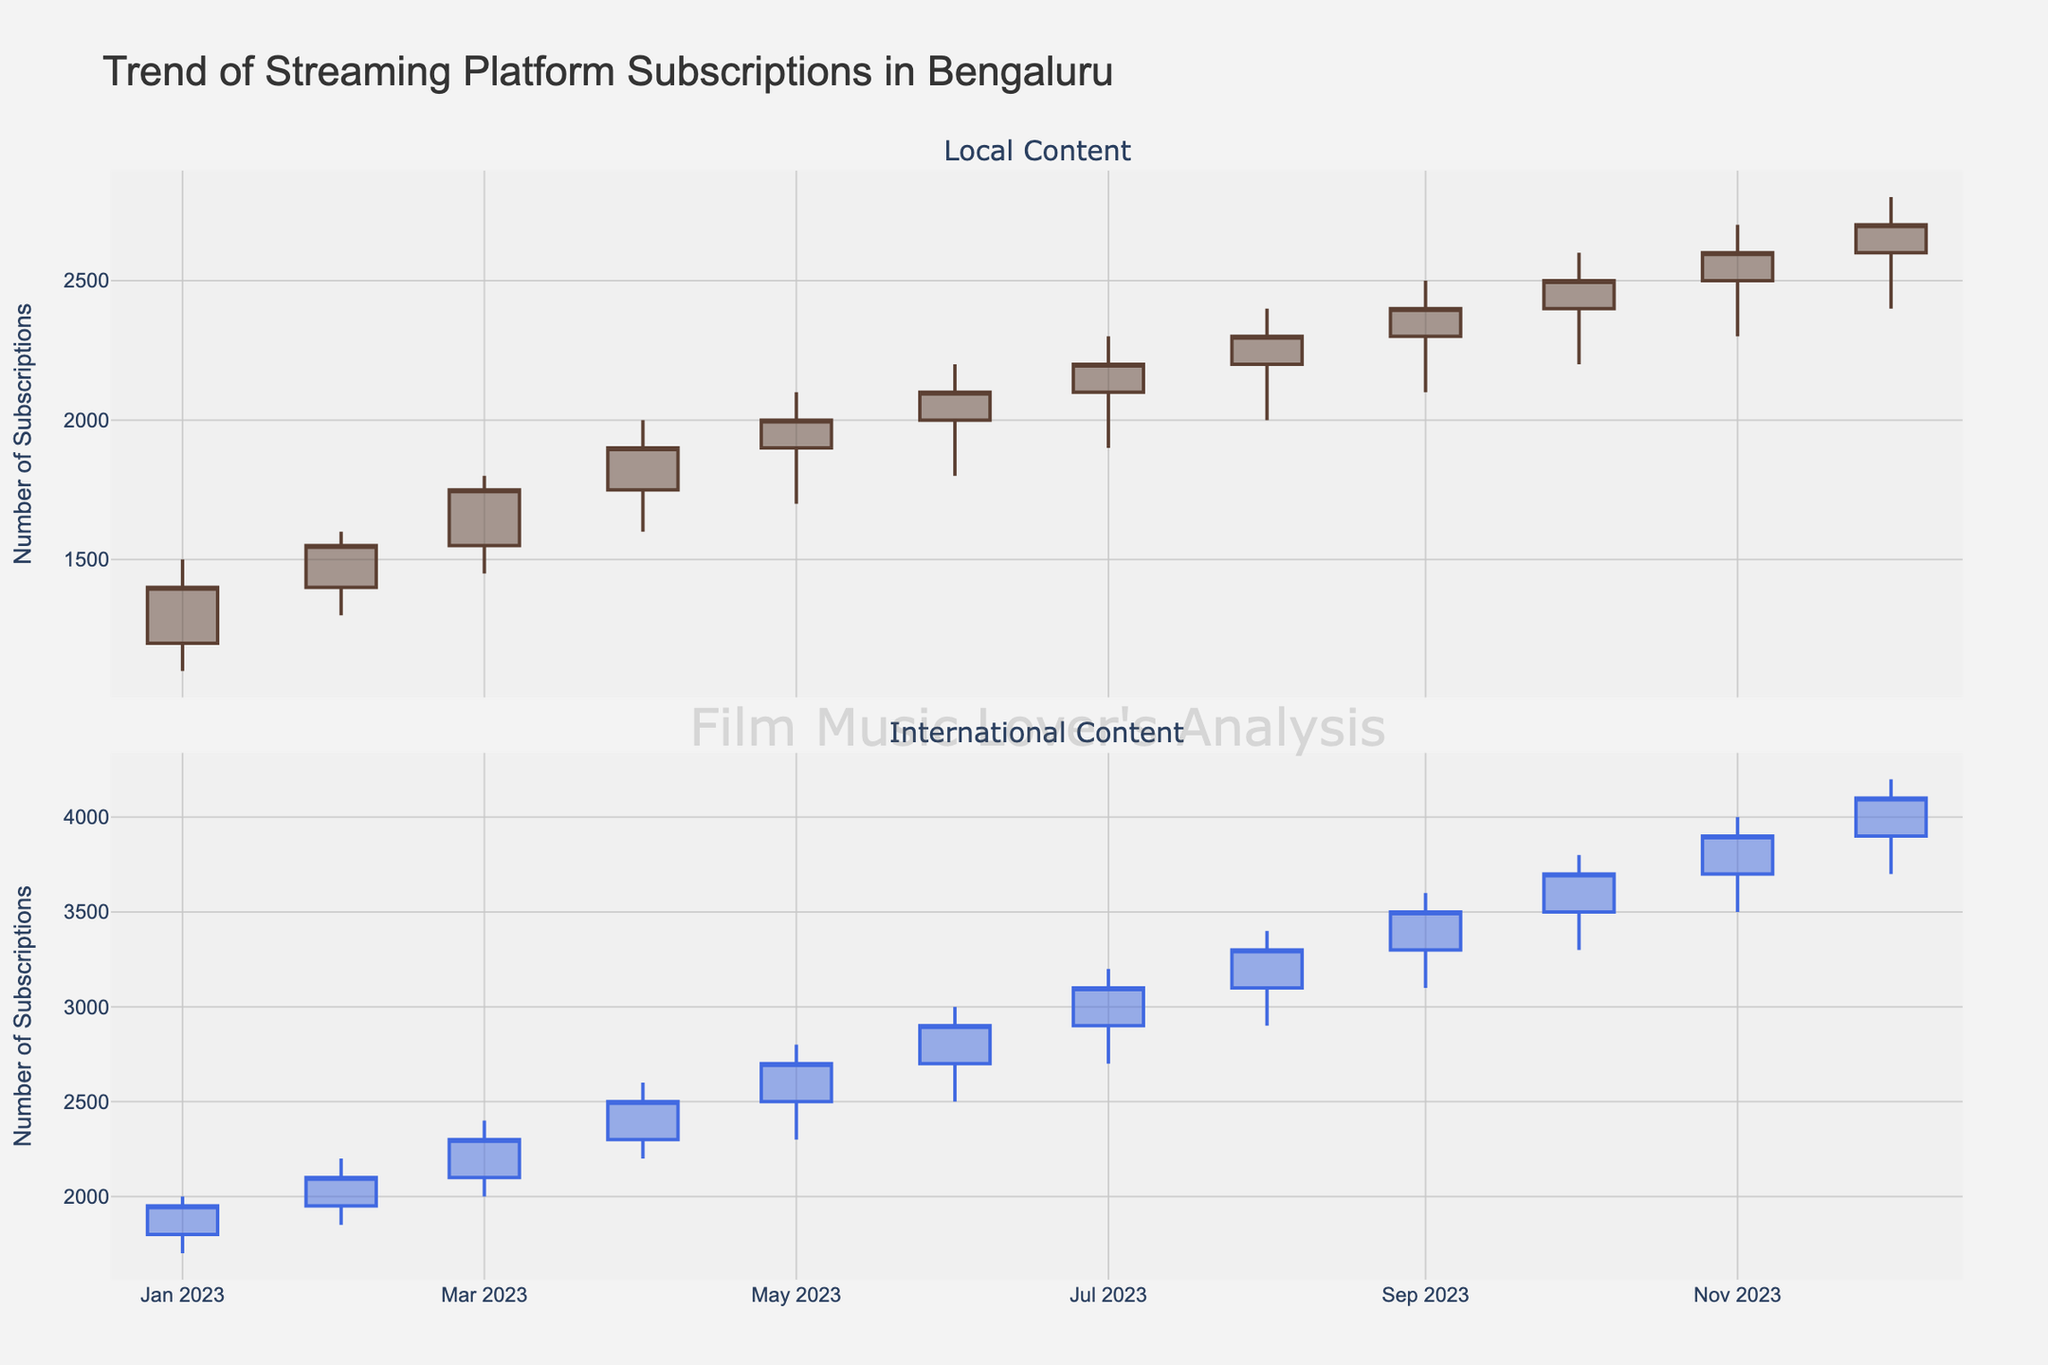What's the title of the figure? The title is located at the top center of the plot. It reads "Trend of Streaming Platform Subscriptions in Bengaluru".
Answer: Trend of Streaming Platform Subscriptions in Bengaluru How many months of data are displayed in the plot? The x-axis shows months from "Jan-2023" to "Dec-2023", indicating that there are 12 months of data displayed.
Answer: 12 Which content type has a higher number of subscriptions in December 2023? By looking at the closing values for December 2023, the local content has a closing value of 2700, while international content has a closing value of 4100.
Answer: International Content What is the highest high value for local content? By observing the highest high values in the first subplot (local content), the highest high value is seen in December 2023, which is 2800.
Answer: 2800 Which month shows the largest increase in international content subscriptions? We need to find the month with the largest gap between the opening and closing values for international content. Reviewing each month's candlestick, August to September shows the largest increase from (3100 to 3500) with a difference of 400.
Answer: September-2023 What was the closing value for local content subscriptions in June 2023? In the first subplot, locate June 2023 and observe the closing value, which is the top edge of the candlestick body, which is 2100.
Answer: 2100 How does the trend of local content subscriptions compare with international content subscriptions over the year? The local content starts lower and has a more gradual increase, whereas international content starts higher and shows a steeper increase over time. Thus, international content grows faster.
Answer: International content grows faster What is the average closing value of local content for the first six months of 2023? Sum the closing values for January to June 2023, which are (1400+1550+1750+1900+2000+2100) = 10700. Divide by 6 to get the average, which is 10700/6 ≈ 1783.33.
Answer: 1783.33 During which month does international content have the smallest spread between high and low values? Check each candlestick's top and bottom shadow lengths for international content. In August 2023, the smallest spread is recorded, calculated as (3400 - 2900) = 500.
Answer: August-2023 What is the common color used in both subplots to indicate an increase in subscriptions? Observing the upward-moving candlesticks in both plots, the increasing color for local content is a shade of brown, and for international content, it is a shade of blue.
Answer: Shade of brown and blue 